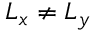Convert formula to latex. <formula><loc_0><loc_0><loc_500><loc_500>L _ { x } \neq L _ { y }</formula> 